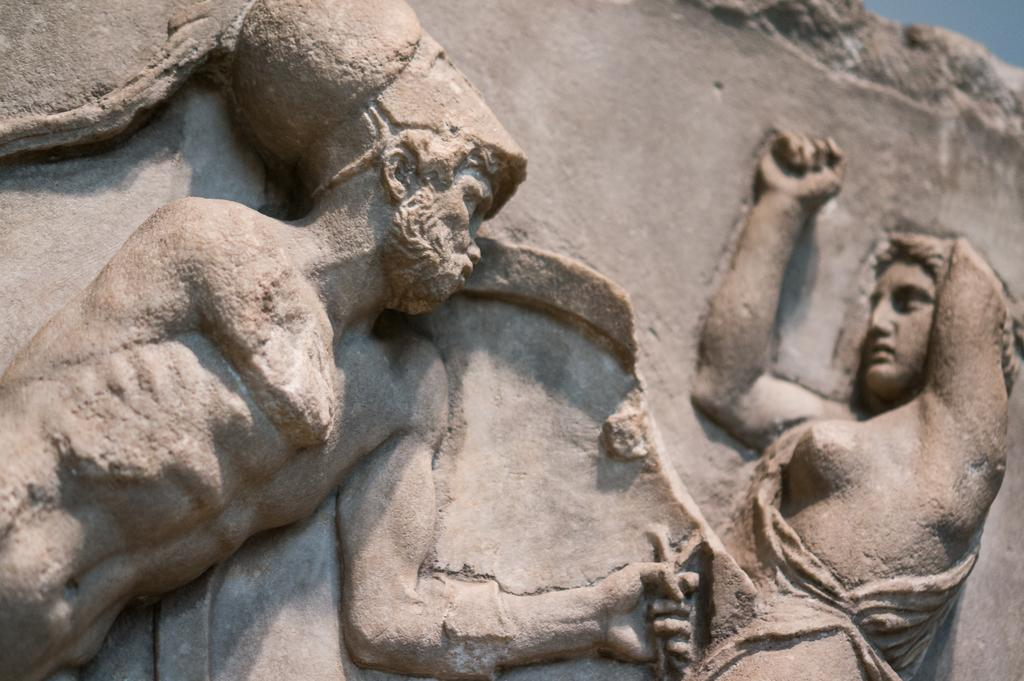What type of objects are featured in the image? There are sculptures in the image. What type of art can be seen in the image? There is no specific type of art mentioned in the image; it only states that there are sculptures present. Can you see a turkey or a plane in the image? No, there is no mention of a turkey or a plane in the image; it only states that there are sculptures present. 